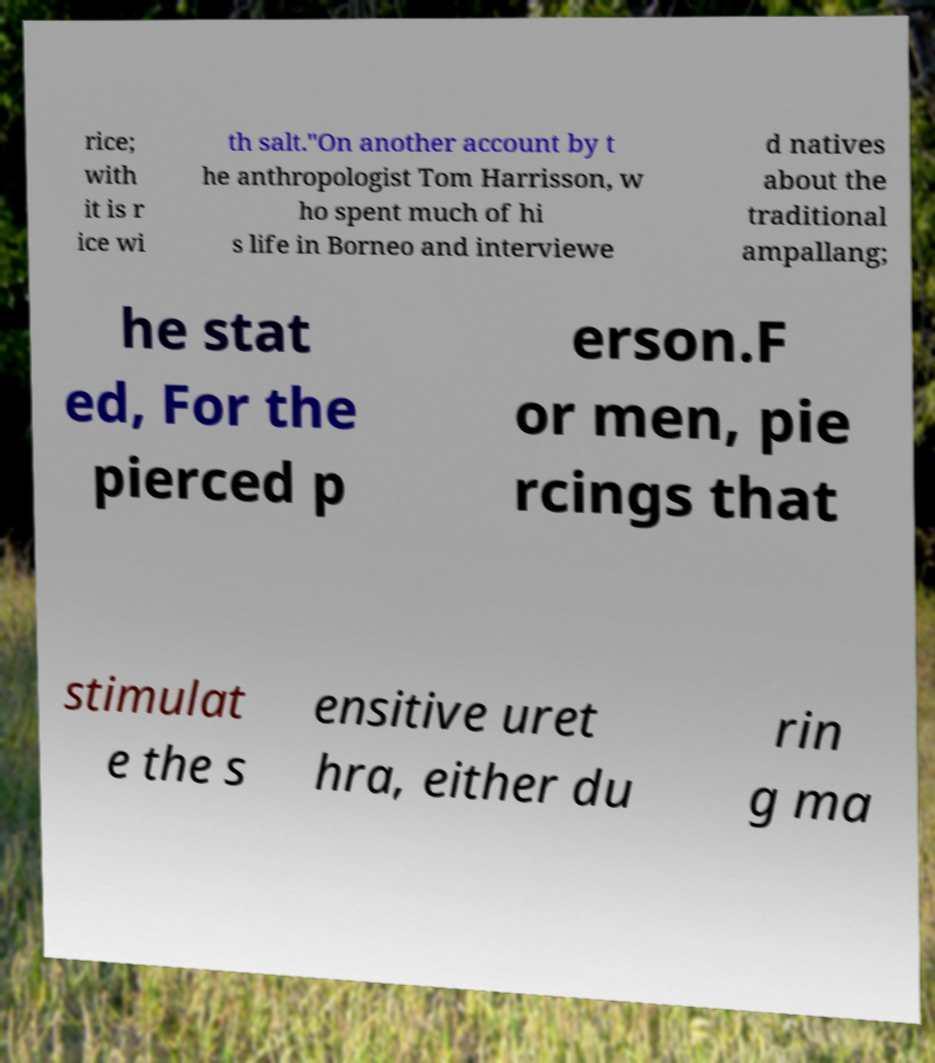Can you accurately transcribe the text from the provided image for me? rice; with it is r ice wi th salt."On another account by t he anthropologist Tom Harrisson, w ho spent much of hi s life in Borneo and interviewe d natives about the traditional ampallang; he stat ed, For the pierced p erson.F or men, pie rcings that stimulat e the s ensitive uret hra, either du rin g ma 